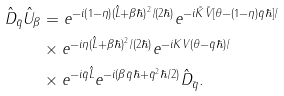<formula> <loc_0><loc_0><loc_500><loc_500>\hat { D } _ { \bar { q } } \hat { U } _ { \beta } & = e ^ { - i \left ( 1 - \eta \right ) ( \hat { L } + \beta \hbar { ) } ^ { 2 } / ( 2 \hbar { ) } } e ^ { - i \tilde { K } \tilde { V } [ \theta - ( 1 - \eta ) \bar { q } \hbar { ] } / } \\ & \times e ^ { - i \eta ( \hat { L } + \beta \hbar { ) } ^ { 2 } / ( 2 \hbar { ) } } e ^ { - i K V ( \theta - \bar { q } \hbar { ) } / } \\ & \times e ^ { - i \bar { q } \hat { L } } e ^ { - i ( \beta \bar { q } \hbar { + } \bar { q } ^ { 2 } \hbar { / } 2 ) } \hat { D } _ { \bar { q } } .</formula> 